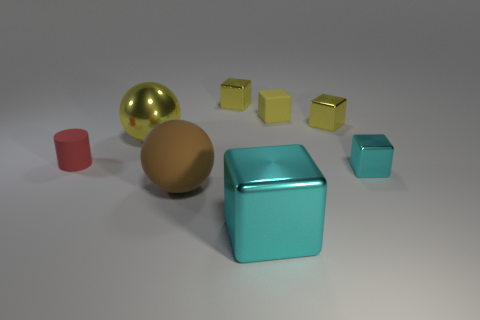Are there any red objects of the same shape as the brown rubber thing?
Your answer should be compact. No. How big is the ball behind the small rubber thing that is in front of the small yellow object that is in front of the small yellow rubber object?
Provide a succinct answer. Large. Are there an equal number of red rubber things that are behind the big metallic sphere and objects that are behind the large metal block?
Provide a short and direct response. No. There is a block that is made of the same material as the small cylinder; what is its size?
Keep it short and to the point. Small. The small rubber block has what color?
Your answer should be very brief. Yellow. How many big matte objects have the same color as the small matte cylinder?
Offer a terse response. 0. There is a red cylinder that is the same size as the yellow rubber cube; what material is it?
Provide a short and direct response. Rubber. Is there a yellow metallic object that is behind the small rubber object that is in front of the big yellow shiny object?
Give a very brief answer. Yes. What number of other things are the same color as the small cylinder?
Your answer should be very brief. 0. How big is the brown object?
Provide a short and direct response. Large. 